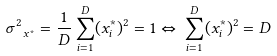<formula> <loc_0><loc_0><loc_500><loc_500>\sigma _ { \ x ^ { * } } ^ { 2 } = \frac { 1 } { D } \sum _ { i = 1 } ^ { D } ( x ^ { * } _ { i } ) ^ { 2 } = 1 \Leftrightarrow \, \sum _ { i = 1 } ^ { D } ( x ^ { * } _ { i } ) ^ { 2 } = D</formula> 